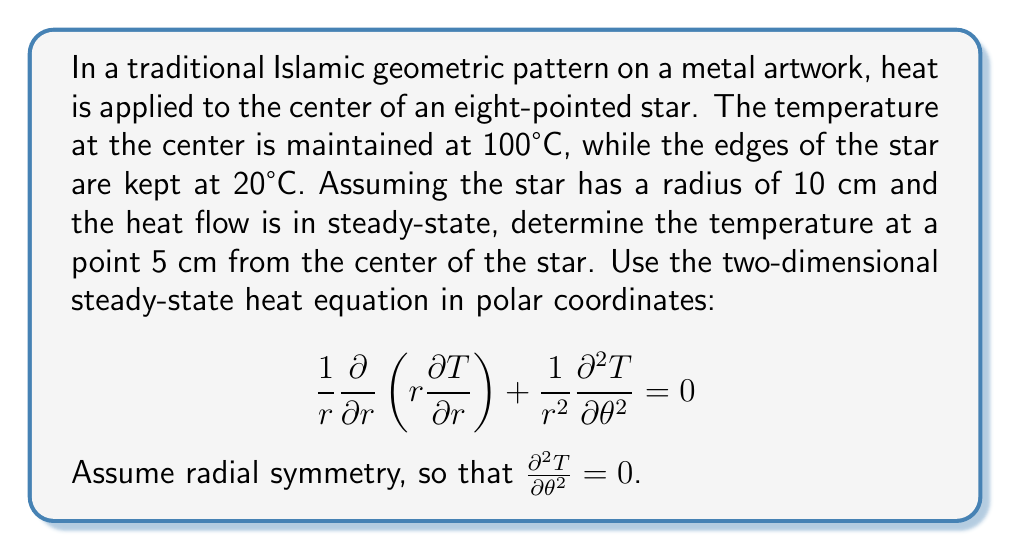Solve this math problem. Let's approach this problem step-by-step:

1) Given the radial symmetry, our heat equation simplifies to:

   $$\frac{1}{r}\frac{d}{dr}\left(r\frac{dT}{dr}\right) = 0$$

2) Integrating both sides with respect to $r$:

   $$r\frac{dT}{dr} = C_1$$

3) Separating variables and integrating again:

   $$T = C_1 \ln(r) + C_2$$

4) Now, we apply the boundary conditions:
   At $r = 0$ cm, $T = 100°C$
   At $r = 10$ cm, $T = 20°C$

5) Applying the second condition:

   $$20 = C_1 \ln(10) + C_2$$

6) We can't apply the first condition directly as $\ln(0)$ is undefined. Instead, we use the fact that temperature must be finite at $r = 0$. This is only possible if $C_1 = 0$.

7) From step 6, we get:

   $$T = C_2 = 20°C$$

8) This constant temperature throughout the star might seem counterintuitive, but it's a consequence of the steady-state assumption and the simplified model we're using.

9) Therefore, at 5 cm from the center, the temperature remains 20°C.
Answer: 20°C 